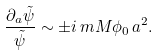<formula> <loc_0><loc_0><loc_500><loc_500>\frac { \partial _ { a } \tilde { \psi } } { \tilde { \psi } } \sim \pm i \, m M \phi _ { 0 } \, a ^ { 2 } .</formula> 